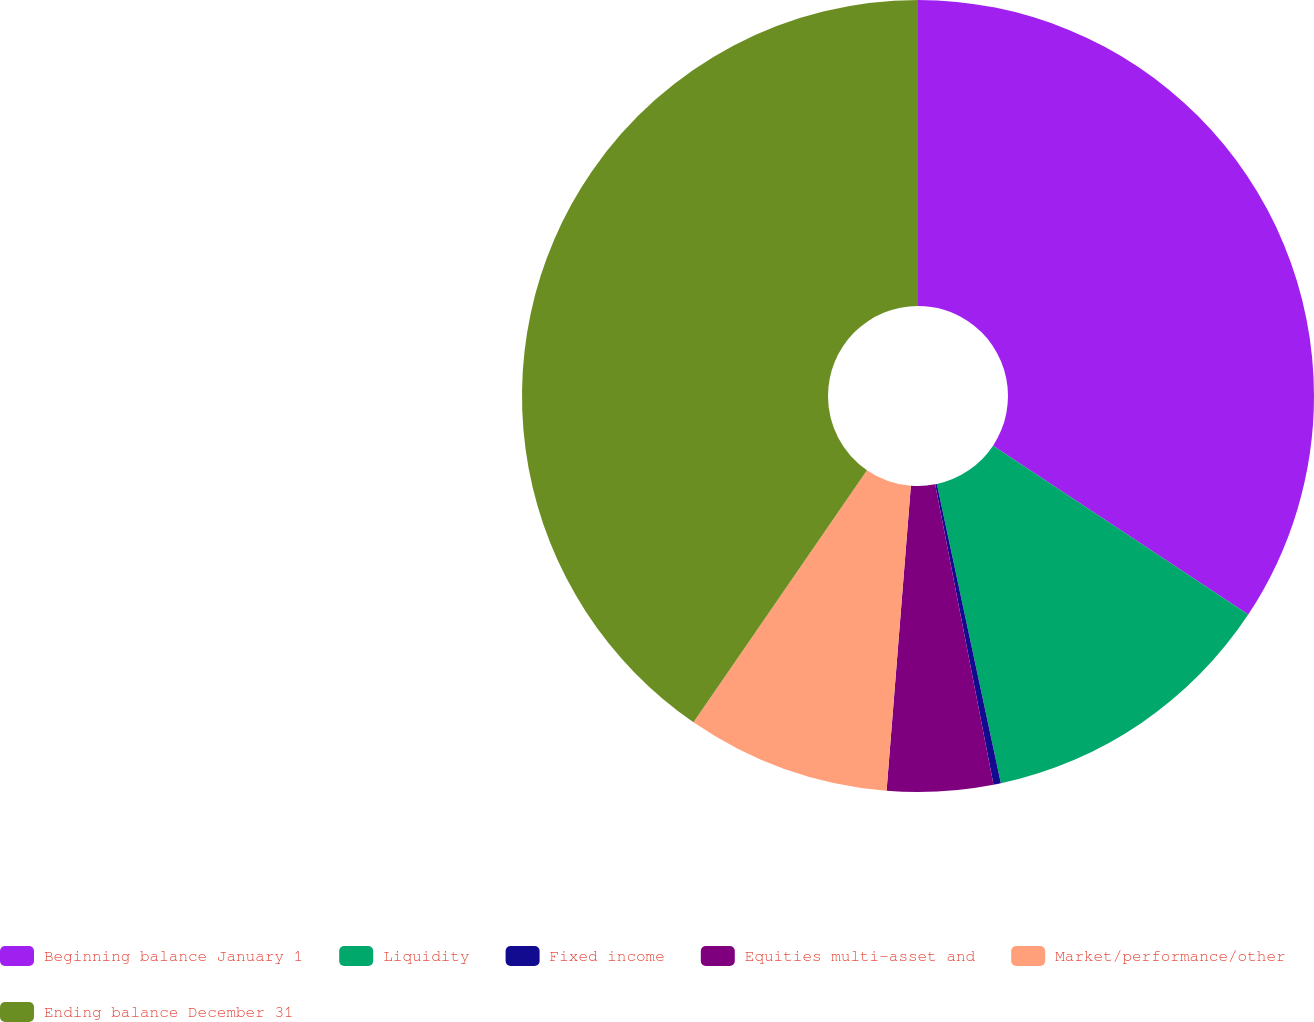Convert chart. <chart><loc_0><loc_0><loc_500><loc_500><pie_chart><fcel>Beginning balance January 1<fcel>Liquidity<fcel>Fixed income<fcel>Equities multi-asset and<fcel>Market/performance/other<fcel>Ending balance December 31<nl><fcel>34.31%<fcel>12.34%<fcel>0.3%<fcel>4.32%<fcel>8.33%<fcel>40.41%<nl></chart> 